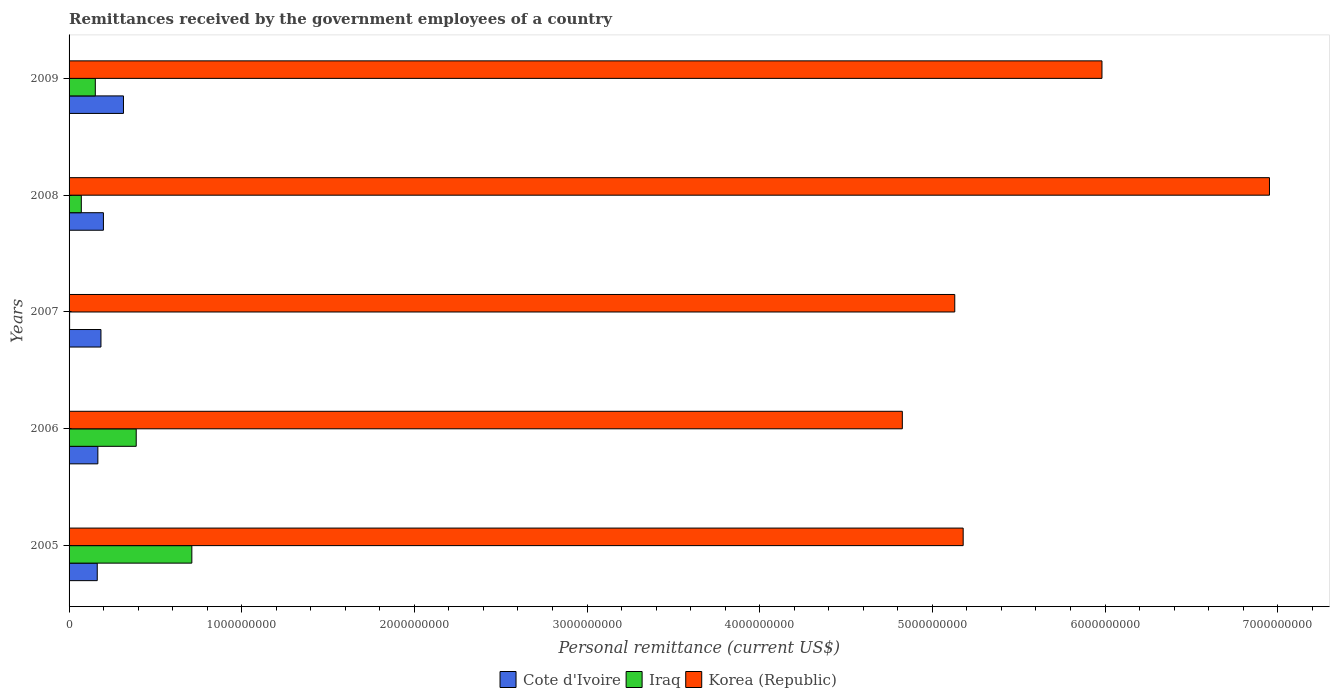Are the number of bars per tick equal to the number of legend labels?
Provide a succinct answer. Yes. How many bars are there on the 1st tick from the bottom?
Provide a short and direct response. 3. What is the remittances received by the government employees in Iraq in 2008?
Your answer should be very brief. 7.09e+07. Across all years, what is the maximum remittances received by the government employees in Cote d'Ivoire?
Your response must be concise. 3.15e+08. Across all years, what is the minimum remittances received by the government employees in Korea (Republic)?
Offer a very short reply. 4.83e+09. In which year was the remittances received by the government employees in Korea (Republic) maximum?
Offer a very short reply. 2008. In which year was the remittances received by the government employees in Korea (Republic) minimum?
Offer a very short reply. 2006. What is the total remittances received by the government employees in Iraq in the graph?
Make the answer very short. 1.33e+09. What is the difference between the remittances received by the government employees in Cote d'Ivoire in 2006 and that in 2008?
Make the answer very short. -3.22e+07. What is the difference between the remittances received by the government employees in Korea (Republic) in 2005 and the remittances received by the government employees in Iraq in 2007?
Keep it short and to the point. 5.18e+09. What is the average remittances received by the government employees in Iraq per year?
Keep it short and to the point. 2.65e+08. In the year 2008, what is the difference between the remittances received by the government employees in Korea (Republic) and remittances received by the government employees in Cote d'Ivoire?
Your answer should be very brief. 6.75e+09. In how many years, is the remittances received by the government employees in Korea (Republic) greater than 2800000000 US$?
Your response must be concise. 5. What is the ratio of the remittances received by the government employees in Iraq in 2006 to that in 2008?
Keep it short and to the point. 5.49. Is the remittances received by the government employees in Korea (Republic) in 2007 less than that in 2009?
Provide a short and direct response. Yes. What is the difference between the highest and the second highest remittances received by the government employees in Korea (Republic)?
Your answer should be compact. 9.70e+08. What is the difference between the highest and the lowest remittances received by the government employees in Korea (Republic)?
Provide a short and direct response. 2.13e+09. In how many years, is the remittances received by the government employees in Korea (Republic) greater than the average remittances received by the government employees in Korea (Republic) taken over all years?
Provide a short and direct response. 2. Is the sum of the remittances received by the government employees in Cote d'Ivoire in 2008 and 2009 greater than the maximum remittances received by the government employees in Korea (Republic) across all years?
Offer a terse response. No. What does the 1st bar from the top in 2009 represents?
Your answer should be compact. Korea (Republic). What does the 3rd bar from the bottom in 2007 represents?
Offer a terse response. Korea (Republic). How many bars are there?
Offer a terse response. 15. How many years are there in the graph?
Give a very brief answer. 5. Does the graph contain any zero values?
Your answer should be very brief. No. Does the graph contain grids?
Keep it short and to the point. No. How many legend labels are there?
Provide a short and direct response. 3. What is the title of the graph?
Keep it short and to the point. Remittances received by the government employees of a country. Does "Central African Republic" appear as one of the legend labels in the graph?
Your answer should be very brief. No. What is the label or title of the X-axis?
Your answer should be compact. Personal remittance (current US$). What is the label or title of the Y-axis?
Your answer should be compact. Years. What is the Personal remittance (current US$) of Cote d'Ivoire in 2005?
Offer a very short reply. 1.63e+08. What is the Personal remittance (current US$) in Iraq in 2005?
Ensure brevity in your answer.  7.11e+08. What is the Personal remittance (current US$) in Korea (Republic) in 2005?
Provide a short and direct response. 5.18e+09. What is the Personal remittance (current US$) in Cote d'Ivoire in 2006?
Ensure brevity in your answer.  1.67e+08. What is the Personal remittance (current US$) in Iraq in 2006?
Provide a short and direct response. 3.89e+08. What is the Personal remittance (current US$) in Korea (Republic) in 2006?
Give a very brief answer. 4.83e+09. What is the Personal remittance (current US$) of Cote d'Ivoire in 2007?
Offer a terse response. 1.85e+08. What is the Personal remittance (current US$) of Iraq in 2007?
Provide a succinct answer. 3.10e+06. What is the Personal remittance (current US$) in Korea (Republic) in 2007?
Ensure brevity in your answer.  5.13e+09. What is the Personal remittance (current US$) of Cote d'Ivoire in 2008?
Offer a terse response. 1.99e+08. What is the Personal remittance (current US$) in Iraq in 2008?
Your answer should be compact. 7.09e+07. What is the Personal remittance (current US$) of Korea (Republic) in 2008?
Your answer should be very brief. 6.95e+09. What is the Personal remittance (current US$) in Cote d'Ivoire in 2009?
Make the answer very short. 3.15e+08. What is the Personal remittance (current US$) of Iraq in 2009?
Provide a short and direct response. 1.52e+08. What is the Personal remittance (current US$) in Korea (Republic) in 2009?
Your answer should be compact. 5.98e+09. Across all years, what is the maximum Personal remittance (current US$) of Cote d'Ivoire?
Provide a short and direct response. 3.15e+08. Across all years, what is the maximum Personal remittance (current US$) in Iraq?
Give a very brief answer. 7.11e+08. Across all years, what is the maximum Personal remittance (current US$) in Korea (Republic)?
Give a very brief answer. 6.95e+09. Across all years, what is the minimum Personal remittance (current US$) of Cote d'Ivoire?
Provide a short and direct response. 1.63e+08. Across all years, what is the minimum Personal remittance (current US$) in Iraq?
Your answer should be very brief. 3.10e+06. Across all years, what is the minimum Personal remittance (current US$) of Korea (Republic)?
Provide a short and direct response. 4.83e+09. What is the total Personal remittance (current US$) in Cote d'Ivoire in the graph?
Provide a succinct answer. 1.03e+09. What is the total Personal remittance (current US$) of Iraq in the graph?
Make the answer very short. 1.33e+09. What is the total Personal remittance (current US$) of Korea (Republic) in the graph?
Your answer should be very brief. 2.81e+1. What is the difference between the Personal remittance (current US$) in Cote d'Ivoire in 2005 and that in 2006?
Ensure brevity in your answer.  -3.59e+06. What is the difference between the Personal remittance (current US$) in Iraq in 2005 and that in 2006?
Give a very brief answer. 3.22e+08. What is the difference between the Personal remittance (current US$) in Korea (Republic) in 2005 and that in 2006?
Offer a very short reply. 3.52e+08. What is the difference between the Personal remittance (current US$) in Cote d'Ivoire in 2005 and that in 2007?
Your response must be concise. -2.15e+07. What is the difference between the Personal remittance (current US$) in Iraq in 2005 and that in 2007?
Your answer should be very brief. 7.08e+08. What is the difference between the Personal remittance (current US$) in Korea (Republic) in 2005 and that in 2007?
Your answer should be compact. 4.87e+07. What is the difference between the Personal remittance (current US$) in Cote d'Ivoire in 2005 and that in 2008?
Give a very brief answer. -3.57e+07. What is the difference between the Personal remittance (current US$) in Iraq in 2005 and that in 2008?
Offer a terse response. 6.40e+08. What is the difference between the Personal remittance (current US$) of Korea (Republic) in 2005 and that in 2008?
Provide a short and direct response. -1.77e+09. What is the difference between the Personal remittance (current US$) in Cote d'Ivoire in 2005 and that in 2009?
Keep it short and to the point. -1.52e+08. What is the difference between the Personal remittance (current US$) in Iraq in 2005 and that in 2009?
Offer a very short reply. 5.59e+08. What is the difference between the Personal remittance (current US$) of Korea (Republic) in 2005 and that in 2009?
Keep it short and to the point. -8.04e+08. What is the difference between the Personal remittance (current US$) of Cote d'Ivoire in 2006 and that in 2007?
Your answer should be compact. -1.79e+07. What is the difference between the Personal remittance (current US$) in Iraq in 2006 and that in 2007?
Keep it short and to the point. 3.86e+08. What is the difference between the Personal remittance (current US$) of Korea (Republic) in 2006 and that in 2007?
Ensure brevity in your answer.  -3.04e+08. What is the difference between the Personal remittance (current US$) of Cote d'Ivoire in 2006 and that in 2008?
Your answer should be very brief. -3.22e+07. What is the difference between the Personal remittance (current US$) of Iraq in 2006 and that in 2008?
Ensure brevity in your answer.  3.18e+08. What is the difference between the Personal remittance (current US$) of Korea (Republic) in 2006 and that in 2008?
Your response must be concise. -2.13e+09. What is the difference between the Personal remittance (current US$) in Cote d'Ivoire in 2006 and that in 2009?
Offer a very short reply. -1.48e+08. What is the difference between the Personal remittance (current US$) in Iraq in 2006 and that in 2009?
Offer a terse response. 2.37e+08. What is the difference between the Personal remittance (current US$) in Korea (Republic) in 2006 and that in 2009?
Provide a short and direct response. -1.16e+09. What is the difference between the Personal remittance (current US$) of Cote d'Ivoire in 2007 and that in 2008?
Your response must be concise. -1.42e+07. What is the difference between the Personal remittance (current US$) in Iraq in 2007 and that in 2008?
Keep it short and to the point. -6.78e+07. What is the difference between the Personal remittance (current US$) in Korea (Republic) in 2007 and that in 2008?
Give a very brief answer. -1.82e+09. What is the difference between the Personal remittance (current US$) in Cote d'Ivoire in 2007 and that in 2009?
Offer a terse response. -1.30e+08. What is the difference between the Personal remittance (current US$) of Iraq in 2007 and that in 2009?
Give a very brief answer. -1.49e+08. What is the difference between the Personal remittance (current US$) of Korea (Republic) in 2007 and that in 2009?
Keep it short and to the point. -8.53e+08. What is the difference between the Personal remittance (current US$) in Cote d'Ivoire in 2008 and that in 2009?
Offer a very short reply. -1.16e+08. What is the difference between the Personal remittance (current US$) of Iraq in 2008 and that in 2009?
Offer a very short reply. -8.11e+07. What is the difference between the Personal remittance (current US$) of Korea (Republic) in 2008 and that in 2009?
Your answer should be compact. 9.70e+08. What is the difference between the Personal remittance (current US$) of Cote d'Ivoire in 2005 and the Personal remittance (current US$) of Iraq in 2006?
Provide a succinct answer. -2.26e+08. What is the difference between the Personal remittance (current US$) of Cote d'Ivoire in 2005 and the Personal remittance (current US$) of Korea (Republic) in 2006?
Keep it short and to the point. -4.66e+09. What is the difference between the Personal remittance (current US$) in Iraq in 2005 and the Personal remittance (current US$) in Korea (Republic) in 2006?
Offer a very short reply. -4.11e+09. What is the difference between the Personal remittance (current US$) in Cote d'Ivoire in 2005 and the Personal remittance (current US$) in Iraq in 2007?
Offer a terse response. 1.60e+08. What is the difference between the Personal remittance (current US$) in Cote d'Ivoire in 2005 and the Personal remittance (current US$) in Korea (Republic) in 2007?
Your answer should be very brief. -4.97e+09. What is the difference between the Personal remittance (current US$) of Iraq in 2005 and the Personal remittance (current US$) of Korea (Republic) in 2007?
Offer a very short reply. -4.42e+09. What is the difference between the Personal remittance (current US$) in Cote d'Ivoire in 2005 and the Personal remittance (current US$) in Iraq in 2008?
Your answer should be very brief. 9.23e+07. What is the difference between the Personal remittance (current US$) in Cote d'Ivoire in 2005 and the Personal remittance (current US$) in Korea (Republic) in 2008?
Give a very brief answer. -6.79e+09. What is the difference between the Personal remittance (current US$) of Iraq in 2005 and the Personal remittance (current US$) of Korea (Republic) in 2008?
Provide a short and direct response. -6.24e+09. What is the difference between the Personal remittance (current US$) of Cote d'Ivoire in 2005 and the Personal remittance (current US$) of Iraq in 2009?
Offer a very short reply. 1.12e+07. What is the difference between the Personal remittance (current US$) of Cote d'Ivoire in 2005 and the Personal remittance (current US$) of Korea (Republic) in 2009?
Provide a succinct answer. -5.82e+09. What is the difference between the Personal remittance (current US$) in Iraq in 2005 and the Personal remittance (current US$) in Korea (Republic) in 2009?
Provide a short and direct response. -5.27e+09. What is the difference between the Personal remittance (current US$) in Cote d'Ivoire in 2006 and the Personal remittance (current US$) in Iraq in 2007?
Keep it short and to the point. 1.64e+08. What is the difference between the Personal remittance (current US$) in Cote d'Ivoire in 2006 and the Personal remittance (current US$) in Korea (Republic) in 2007?
Your answer should be compact. -4.96e+09. What is the difference between the Personal remittance (current US$) of Iraq in 2006 and the Personal remittance (current US$) of Korea (Republic) in 2007?
Ensure brevity in your answer.  -4.74e+09. What is the difference between the Personal remittance (current US$) of Cote d'Ivoire in 2006 and the Personal remittance (current US$) of Iraq in 2008?
Ensure brevity in your answer.  9.59e+07. What is the difference between the Personal remittance (current US$) of Cote d'Ivoire in 2006 and the Personal remittance (current US$) of Korea (Republic) in 2008?
Your answer should be compact. -6.79e+09. What is the difference between the Personal remittance (current US$) in Iraq in 2006 and the Personal remittance (current US$) in Korea (Republic) in 2008?
Keep it short and to the point. -6.56e+09. What is the difference between the Personal remittance (current US$) of Cote d'Ivoire in 2006 and the Personal remittance (current US$) of Iraq in 2009?
Your answer should be compact. 1.48e+07. What is the difference between the Personal remittance (current US$) of Cote d'Ivoire in 2006 and the Personal remittance (current US$) of Korea (Republic) in 2009?
Your answer should be very brief. -5.82e+09. What is the difference between the Personal remittance (current US$) of Iraq in 2006 and the Personal remittance (current US$) of Korea (Republic) in 2009?
Make the answer very short. -5.59e+09. What is the difference between the Personal remittance (current US$) in Cote d'Ivoire in 2007 and the Personal remittance (current US$) in Iraq in 2008?
Give a very brief answer. 1.14e+08. What is the difference between the Personal remittance (current US$) in Cote d'Ivoire in 2007 and the Personal remittance (current US$) in Korea (Republic) in 2008?
Your answer should be very brief. -6.77e+09. What is the difference between the Personal remittance (current US$) in Iraq in 2007 and the Personal remittance (current US$) in Korea (Republic) in 2008?
Give a very brief answer. -6.95e+09. What is the difference between the Personal remittance (current US$) of Cote d'Ivoire in 2007 and the Personal remittance (current US$) of Iraq in 2009?
Ensure brevity in your answer.  3.27e+07. What is the difference between the Personal remittance (current US$) of Cote d'Ivoire in 2007 and the Personal remittance (current US$) of Korea (Republic) in 2009?
Provide a short and direct response. -5.80e+09. What is the difference between the Personal remittance (current US$) in Iraq in 2007 and the Personal remittance (current US$) in Korea (Republic) in 2009?
Ensure brevity in your answer.  -5.98e+09. What is the difference between the Personal remittance (current US$) in Cote d'Ivoire in 2008 and the Personal remittance (current US$) in Iraq in 2009?
Give a very brief answer. 4.69e+07. What is the difference between the Personal remittance (current US$) in Cote d'Ivoire in 2008 and the Personal remittance (current US$) in Korea (Republic) in 2009?
Make the answer very short. -5.78e+09. What is the difference between the Personal remittance (current US$) in Iraq in 2008 and the Personal remittance (current US$) in Korea (Republic) in 2009?
Provide a short and direct response. -5.91e+09. What is the average Personal remittance (current US$) in Cote d'Ivoire per year?
Ensure brevity in your answer.  2.06e+08. What is the average Personal remittance (current US$) of Iraq per year?
Ensure brevity in your answer.  2.65e+08. What is the average Personal remittance (current US$) of Korea (Republic) per year?
Your answer should be compact. 5.61e+09. In the year 2005, what is the difference between the Personal remittance (current US$) in Cote d'Ivoire and Personal remittance (current US$) in Iraq?
Make the answer very short. -5.48e+08. In the year 2005, what is the difference between the Personal remittance (current US$) in Cote d'Ivoire and Personal remittance (current US$) in Korea (Republic)?
Make the answer very short. -5.02e+09. In the year 2005, what is the difference between the Personal remittance (current US$) in Iraq and Personal remittance (current US$) in Korea (Republic)?
Provide a short and direct response. -4.47e+09. In the year 2006, what is the difference between the Personal remittance (current US$) in Cote d'Ivoire and Personal remittance (current US$) in Iraq?
Give a very brief answer. -2.22e+08. In the year 2006, what is the difference between the Personal remittance (current US$) in Cote d'Ivoire and Personal remittance (current US$) in Korea (Republic)?
Ensure brevity in your answer.  -4.66e+09. In the year 2006, what is the difference between the Personal remittance (current US$) of Iraq and Personal remittance (current US$) of Korea (Republic)?
Keep it short and to the point. -4.44e+09. In the year 2007, what is the difference between the Personal remittance (current US$) of Cote d'Ivoire and Personal remittance (current US$) of Iraq?
Offer a very short reply. 1.82e+08. In the year 2007, what is the difference between the Personal remittance (current US$) of Cote d'Ivoire and Personal remittance (current US$) of Korea (Republic)?
Make the answer very short. -4.95e+09. In the year 2007, what is the difference between the Personal remittance (current US$) in Iraq and Personal remittance (current US$) in Korea (Republic)?
Offer a very short reply. -5.13e+09. In the year 2008, what is the difference between the Personal remittance (current US$) in Cote d'Ivoire and Personal remittance (current US$) in Iraq?
Make the answer very short. 1.28e+08. In the year 2008, what is the difference between the Personal remittance (current US$) in Cote d'Ivoire and Personal remittance (current US$) in Korea (Republic)?
Offer a very short reply. -6.75e+09. In the year 2008, what is the difference between the Personal remittance (current US$) of Iraq and Personal remittance (current US$) of Korea (Republic)?
Ensure brevity in your answer.  -6.88e+09. In the year 2009, what is the difference between the Personal remittance (current US$) of Cote d'Ivoire and Personal remittance (current US$) of Iraq?
Your response must be concise. 1.63e+08. In the year 2009, what is the difference between the Personal remittance (current US$) in Cote d'Ivoire and Personal remittance (current US$) in Korea (Republic)?
Make the answer very short. -5.67e+09. In the year 2009, what is the difference between the Personal remittance (current US$) of Iraq and Personal remittance (current US$) of Korea (Republic)?
Your response must be concise. -5.83e+09. What is the ratio of the Personal remittance (current US$) of Cote d'Ivoire in 2005 to that in 2006?
Keep it short and to the point. 0.98. What is the ratio of the Personal remittance (current US$) of Iraq in 2005 to that in 2006?
Offer a terse response. 1.83. What is the ratio of the Personal remittance (current US$) of Korea (Republic) in 2005 to that in 2006?
Give a very brief answer. 1.07. What is the ratio of the Personal remittance (current US$) of Cote d'Ivoire in 2005 to that in 2007?
Give a very brief answer. 0.88. What is the ratio of the Personal remittance (current US$) in Iraq in 2005 to that in 2007?
Your answer should be very brief. 229.39. What is the ratio of the Personal remittance (current US$) in Korea (Republic) in 2005 to that in 2007?
Offer a very short reply. 1.01. What is the ratio of the Personal remittance (current US$) of Cote d'Ivoire in 2005 to that in 2008?
Your answer should be compact. 0.82. What is the ratio of the Personal remittance (current US$) of Iraq in 2005 to that in 2008?
Make the answer very short. 10.03. What is the ratio of the Personal remittance (current US$) of Korea (Republic) in 2005 to that in 2008?
Offer a terse response. 0.74. What is the ratio of the Personal remittance (current US$) of Cote d'Ivoire in 2005 to that in 2009?
Provide a short and direct response. 0.52. What is the ratio of the Personal remittance (current US$) in Iraq in 2005 to that in 2009?
Offer a very short reply. 4.68. What is the ratio of the Personal remittance (current US$) in Korea (Republic) in 2005 to that in 2009?
Offer a terse response. 0.87. What is the ratio of the Personal remittance (current US$) in Cote d'Ivoire in 2006 to that in 2007?
Your answer should be compact. 0.9. What is the ratio of the Personal remittance (current US$) in Iraq in 2006 to that in 2007?
Keep it short and to the point. 125.45. What is the ratio of the Personal remittance (current US$) in Korea (Republic) in 2006 to that in 2007?
Give a very brief answer. 0.94. What is the ratio of the Personal remittance (current US$) of Cote d'Ivoire in 2006 to that in 2008?
Ensure brevity in your answer.  0.84. What is the ratio of the Personal remittance (current US$) of Iraq in 2006 to that in 2008?
Provide a short and direct response. 5.49. What is the ratio of the Personal remittance (current US$) in Korea (Republic) in 2006 to that in 2008?
Provide a short and direct response. 0.69. What is the ratio of the Personal remittance (current US$) in Cote d'Ivoire in 2006 to that in 2009?
Provide a succinct answer. 0.53. What is the ratio of the Personal remittance (current US$) in Iraq in 2006 to that in 2009?
Provide a succinct answer. 2.56. What is the ratio of the Personal remittance (current US$) in Korea (Republic) in 2006 to that in 2009?
Ensure brevity in your answer.  0.81. What is the ratio of the Personal remittance (current US$) of Cote d'Ivoire in 2007 to that in 2008?
Provide a short and direct response. 0.93. What is the ratio of the Personal remittance (current US$) in Iraq in 2007 to that in 2008?
Your answer should be very brief. 0.04. What is the ratio of the Personal remittance (current US$) of Korea (Republic) in 2007 to that in 2008?
Provide a short and direct response. 0.74. What is the ratio of the Personal remittance (current US$) of Cote d'Ivoire in 2007 to that in 2009?
Keep it short and to the point. 0.59. What is the ratio of the Personal remittance (current US$) of Iraq in 2007 to that in 2009?
Offer a very short reply. 0.02. What is the ratio of the Personal remittance (current US$) in Korea (Republic) in 2007 to that in 2009?
Provide a short and direct response. 0.86. What is the ratio of the Personal remittance (current US$) of Cote d'Ivoire in 2008 to that in 2009?
Provide a short and direct response. 0.63. What is the ratio of the Personal remittance (current US$) in Iraq in 2008 to that in 2009?
Make the answer very short. 0.47. What is the ratio of the Personal remittance (current US$) of Korea (Republic) in 2008 to that in 2009?
Provide a succinct answer. 1.16. What is the difference between the highest and the second highest Personal remittance (current US$) in Cote d'Ivoire?
Make the answer very short. 1.16e+08. What is the difference between the highest and the second highest Personal remittance (current US$) in Iraq?
Your answer should be very brief. 3.22e+08. What is the difference between the highest and the second highest Personal remittance (current US$) in Korea (Republic)?
Provide a succinct answer. 9.70e+08. What is the difference between the highest and the lowest Personal remittance (current US$) in Cote d'Ivoire?
Keep it short and to the point. 1.52e+08. What is the difference between the highest and the lowest Personal remittance (current US$) in Iraq?
Your answer should be very brief. 7.08e+08. What is the difference between the highest and the lowest Personal remittance (current US$) of Korea (Republic)?
Your answer should be compact. 2.13e+09. 